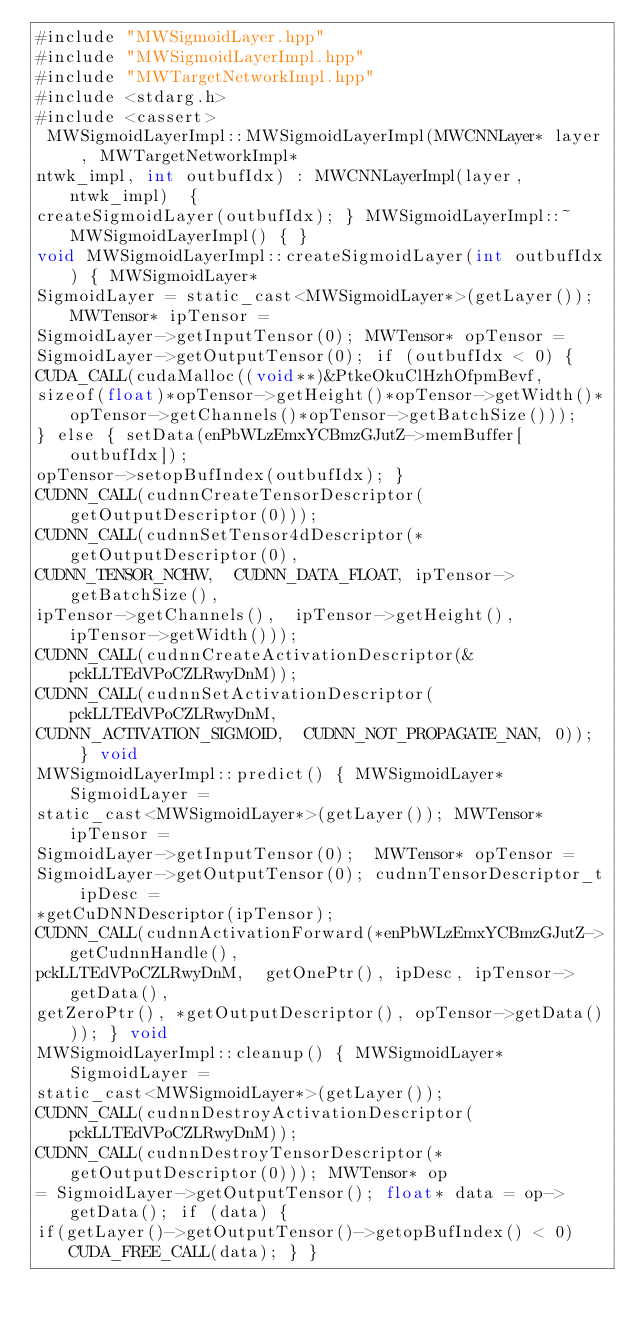<code> <loc_0><loc_0><loc_500><loc_500><_Cuda_>#include "MWSigmoidLayer.hpp"
#include "MWSigmoidLayerImpl.hpp"
#include "MWTargetNetworkImpl.hpp"
#include <stdarg.h>
#include <cassert>
 MWSigmoidLayerImpl::MWSigmoidLayerImpl(MWCNNLayer* layer, MWTargetNetworkImpl* 
ntwk_impl, int outbufIdx) : MWCNNLayerImpl(layer, ntwk_impl)  { 
createSigmoidLayer(outbufIdx); } MWSigmoidLayerImpl::~MWSigmoidLayerImpl() { } 
void MWSigmoidLayerImpl::createSigmoidLayer(int outbufIdx) { MWSigmoidLayer* 
SigmoidLayer = static_cast<MWSigmoidLayer*>(getLayer()); MWTensor* ipTensor = 
SigmoidLayer->getInputTensor(0); MWTensor* opTensor = 
SigmoidLayer->getOutputTensor(0); if (outbufIdx < 0) { 
CUDA_CALL(cudaMalloc((void**)&PtkeOkuClHzhOfpmBevf, 
sizeof(float)*opTensor->getHeight()*opTensor->getWidth()*opTensor->getChannels()*opTensor->getBatchSize())); 
} else { setData(enPbWLzEmxYCBmzGJutZ->memBuffer[outbufIdx]); 
opTensor->setopBufIndex(outbufIdx); } 
CUDNN_CALL(cudnnCreateTensorDescriptor(getOutputDescriptor(0))); 
CUDNN_CALL(cudnnSetTensor4dDescriptor(*getOutputDescriptor(0), 
CUDNN_TENSOR_NCHW,  CUDNN_DATA_FLOAT, ipTensor->getBatchSize(),  
ipTensor->getChannels(),  ipTensor->getHeight(),  ipTensor->getWidth()));  
CUDNN_CALL(cudnnCreateActivationDescriptor(&pckLLTEdVPoCZLRwyDnM)); 
CUDNN_CALL(cudnnSetActivationDescriptor(pckLLTEdVPoCZLRwyDnM, 
CUDNN_ACTIVATION_SIGMOID,  CUDNN_NOT_PROPAGATE_NAN, 0));  } void 
MWSigmoidLayerImpl::predict() { MWSigmoidLayer* SigmoidLayer = 
static_cast<MWSigmoidLayer*>(getLayer()); MWTensor* ipTensor = 
SigmoidLayer->getInputTensor(0);  MWTensor* opTensor = 
SigmoidLayer->getOutputTensor(0); cudnnTensorDescriptor_t ipDesc = 
*getCuDNNDescriptor(ipTensor); 
CUDNN_CALL(cudnnActivationForward(*enPbWLzEmxYCBmzGJutZ->getCudnnHandle(), 
pckLLTEdVPoCZLRwyDnM,  getOnePtr(), ipDesc, ipTensor->getData(), 
getZeroPtr(), *getOutputDescriptor(), opTensor->getData())); } void 
MWSigmoidLayerImpl::cleanup() { MWSigmoidLayer* SigmoidLayer = 
static_cast<MWSigmoidLayer*>(getLayer()); 
CUDNN_CALL(cudnnDestroyActivationDescriptor(pckLLTEdVPoCZLRwyDnM)); 
CUDNN_CALL(cudnnDestroyTensorDescriptor(*getOutputDescriptor(0))); MWTensor* op 
= SigmoidLayer->getOutputTensor(); float* data = op->getData(); if (data) { 
if(getLayer()->getOutputTensor()->getopBufIndex() < 0) CUDA_FREE_CALL(data); } }</code> 